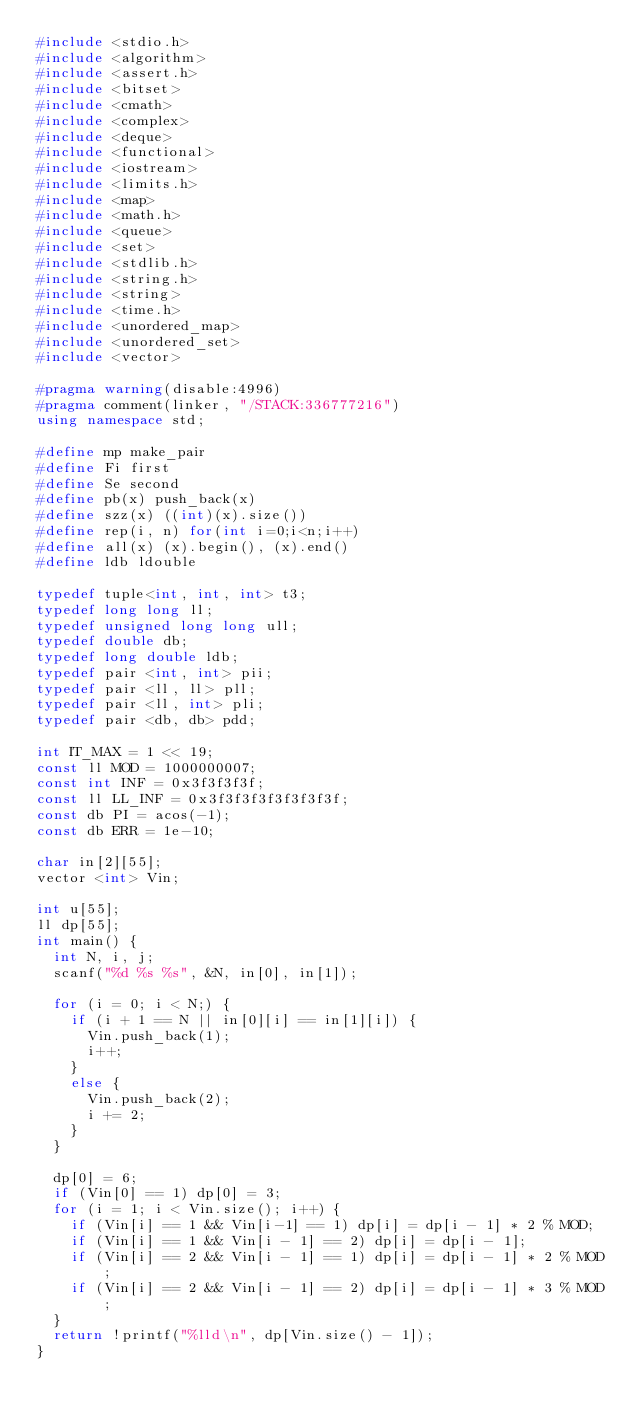<code> <loc_0><loc_0><loc_500><loc_500><_C++_>#include <stdio.h>  
#include <algorithm>  
#include <assert.h>
#include <bitset>
#include <cmath>  
#include <complex>  
#include <deque>  
#include <functional>  
#include <iostream>  
#include <limits.h>  
#include <map>  
#include <math.h>  
#include <queue>  
#include <set>  
#include <stdlib.h>  
#include <string.h>  
#include <string>  
#include <time.h>  
#include <unordered_map>  
#include <unordered_set>  
#include <vector>  

#pragma warning(disable:4996)  
#pragma comment(linker, "/STACK:336777216")  
using namespace std;

#define mp make_pair  
#define Fi first  
#define Se second  
#define pb(x) push_back(x)  
#define szz(x) ((int)(x).size())  
#define rep(i, n) for(int i=0;i<n;i++)  
#define all(x) (x).begin(), (x).end()  
#define ldb ldouble  

typedef tuple<int, int, int> t3;
typedef long long ll;
typedef unsigned long long ull;
typedef double db;
typedef long double ldb;
typedef pair <int, int> pii;
typedef pair <ll, ll> pll;
typedef pair <ll, int> pli;
typedef pair <db, db> pdd;

int IT_MAX = 1 << 19;
const ll MOD = 1000000007;
const int INF = 0x3f3f3f3f;
const ll LL_INF = 0x3f3f3f3f3f3f3f3f;
const db PI = acos(-1);
const db ERR = 1e-10;

char in[2][55];
vector <int> Vin;

int u[55];
ll dp[55];
int main() {
	int N, i, j;
	scanf("%d %s %s", &N, in[0], in[1]);

	for (i = 0; i < N;) {
		if (i + 1 == N || in[0][i] == in[1][i]) {
			Vin.push_back(1);
			i++;
		}
		else {
			Vin.push_back(2);
			i += 2;
		}
	}

	dp[0] = 6;
	if (Vin[0] == 1) dp[0] = 3;
	for (i = 1; i < Vin.size(); i++) {
		if (Vin[i] == 1 && Vin[i-1] == 1) dp[i] = dp[i - 1] * 2 % MOD;
		if (Vin[i] == 1 && Vin[i - 1] == 2) dp[i] = dp[i - 1];
		if (Vin[i] == 2 && Vin[i - 1] == 1) dp[i] = dp[i - 1] * 2 % MOD;
		if (Vin[i] == 2 && Vin[i - 1] == 2) dp[i] = dp[i - 1] * 3 % MOD;
	}
	return !printf("%lld\n", dp[Vin.size() - 1]);
}</code> 